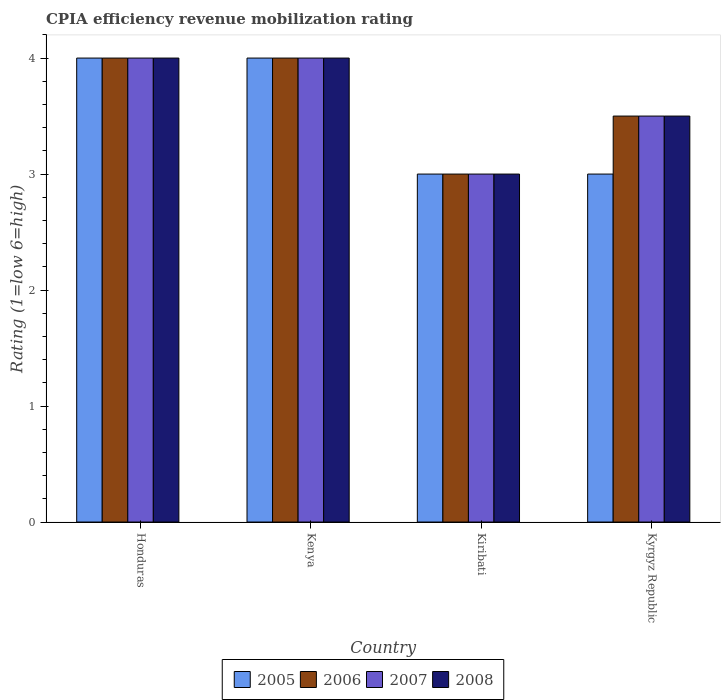How many different coloured bars are there?
Offer a terse response. 4. Are the number of bars per tick equal to the number of legend labels?
Make the answer very short. Yes. Are the number of bars on each tick of the X-axis equal?
Give a very brief answer. Yes. How many bars are there on the 2nd tick from the left?
Give a very brief answer. 4. What is the label of the 4th group of bars from the left?
Offer a very short reply. Kyrgyz Republic. In how many cases, is the number of bars for a given country not equal to the number of legend labels?
Your response must be concise. 0. What is the CPIA rating in 2005 in Honduras?
Your answer should be compact. 4. In which country was the CPIA rating in 2005 maximum?
Provide a succinct answer. Honduras. In which country was the CPIA rating in 2006 minimum?
Ensure brevity in your answer.  Kiribati. What is the difference between the CPIA rating in 2007 in Kenya and that in Kiribati?
Ensure brevity in your answer.  1. What is the difference between the CPIA rating in 2008 in Kyrgyz Republic and the CPIA rating in 2005 in Honduras?
Make the answer very short. -0.5. What is the average CPIA rating in 2007 per country?
Give a very brief answer. 3.62. What is the difference between the CPIA rating of/in 2007 and CPIA rating of/in 2008 in Honduras?
Ensure brevity in your answer.  0. In how many countries, is the CPIA rating in 2008 greater than 2.8?
Your answer should be very brief. 4. What is the ratio of the CPIA rating in 2007 in Honduras to that in Kyrgyz Republic?
Your answer should be very brief. 1.14. Is the CPIA rating in 2006 in Honduras less than that in Kenya?
Your response must be concise. No. Is the difference between the CPIA rating in 2007 in Honduras and Kenya greater than the difference between the CPIA rating in 2008 in Honduras and Kenya?
Offer a terse response. No. What is the difference between the highest and the lowest CPIA rating in 2006?
Keep it short and to the point. 1. In how many countries, is the CPIA rating in 2005 greater than the average CPIA rating in 2005 taken over all countries?
Keep it short and to the point. 2. Is the sum of the CPIA rating in 2007 in Kenya and Kiribati greater than the maximum CPIA rating in 2008 across all countries?
Provide a succinct answer. Yes. What does the 4th bar from the left in Kenya represents?
Provide a short and direct response. 2008. What does the 1st bar from the right in Kyrgyz Republic represents?
Provide a succinct answer. 2008. Are all the bars in the graph horizontal?
Provide a short and direct response. No. What is the difference between two consecutive major ticks on the Y-axis?
Your answer should be very brief. 1. Are the values on the major ticks of Y-axis written in scientific E-notation?
Your answer should be very brief. No. Does the graph contain grids?
Provide a succinct answer. No. Where does the legend appear in the graph?
Your response must be concise. Bottom center. How many legend labels are there?
Offer a very short reply. 4. How are the legend labels stacked?
Offer a very short reply. Horizontal. What is the title of the graph?
Make the answer very short. CPIA efficiency revenue mobilization rating. Does "1960" appear as one of the legend labels in the graph?
Your response must be concise. No. What is the Rating (1=low 6=high) in 2006 in Honduras?
Your answer should be compact. 4. What is the Rating (1=low 6=high) of 2008 in Honduras?
Offer a very short reply. 4. What is the Rating (1=low 6=high) of 2005 in Kenya?
Make the answer very short. 4. What is the Rating (1=low 6=high) in 2008 in Kenya?
Ensure brevity in your answer.  4. What is the Rating (1=low 6=high) in 2006 in Kiribati?
Offer a very short reply. 3. What is the Rating (1=low 6=high) in 2005 in Kyrgyz Republic?
Offer a very short reply. 3. What is the Rating (1=low 6=high) in 2006 in Kyrgyz Republic?
Your answer should be very brief. 3.5. Across all countries, what is the maximum Rating (1=low 6=high) in 2005?
Give a very brief answer. 4. Across all countries, what is the maximum Rating (1=low 6=high) of 2006?
Keep it short and to the point. 4. What is the total Rating (1=low 6=high) in 2006 in the graph?
Offer a very short reply. 14.5. What is the difference between the Rating (1=low 6=high) in 2005 in Honduras and that in Kenya?
Provide a succinct answer. 0. What is the difference between the Rating (1=low 6=high) in 2007 in Honduras and that in Kenya?
Ensure brevity in your answer.  0. What is the difference between the Rating (1=low 6=high) of 2005 in Honduras and that in Kiribati?
Your response must be concise. 1. What is the difference between the Rating (1=low 6=high) of 2007 in Honduras and that in Kiribati?
Offer a terse response. 1. What is the difference between the Rating (1=low 6=high) of 2008 in Honduras and that in Kiribati?
Make the answer very short. 1. What is the difference between the Rating (1=low 6=high) in 2006 in Kenya and that in Kiribati?
Make the answer very short. 1. What is the difference between the Rating (1=low 6=high) of 2008 in Kenya and that in Kiribati?
Provide a succinct answer. 1. What is the difference between the Rating (1=low 6=high) of 2005 in Kenya and that in Kyrgyz Republic?
Your answer should be compact. 1. What is the difference between the Rating (1=low 6=high) of 2005 in Kiribati and that in Kyrgyz Republic?
Make the answer very short. 0. What is the difference between the Rating (1=low 6=high) in 2007 in Kiribati and that in Kyrgyz Republic?
Ensure brevity in your answer.  -0.5. What is the difference between the Rating (1=low 6=high) in 2005 in Honduras and the Rating (1=low 6=high) in 2006 in Kenya?
Provide a succinct answer. 0. What is the difference between the Rating (1=low 6=high) of 2005 in Honduras and the Rating (1=low 6=high) of 2008 in Kenya?
Your answer should be very brief. 0. What is the difference between the Rating (1=low 6=high) in 2006 in Honduras and the Rating (1=low 6=high) in 2008 in Kenya?
Your response must be concise. 0. What is the difference between the Rating (1=low 6=high) in 2007 in Honduras and the Rating (1=low 6=high) in 2008 in Kenya?
Offer a very short reply. 0. What is the difference between the Rating (1=low 6=high) in 2005 in Honduras and the Rating (1=low 6=high) in 2006 in Kiribati?
Your answer should be compact. 1. What is the difference between the Rating (1=low 6=high) in 2005 in Honduras and the Rating (1=low 6=high) in 2007 in Kiribati?
Give a very brief answer. 1. What is the difference between the Rating (1=low 6=high) in 2005 in Honduras and the Rating (1=low 6=high) in 2008 in Kiribati?
Ensure brevity in your answer.  1. What is the difference between the Rating (1=low 6=high) of 2006 in Honduras and the Rating (1=low 6=high) of 2008 in Kiribati?
Your answer should be compact. 1. What is the difference between the Rating (1=low 6=high) of 2005 in Honduras and the Rating (1=low 6=high) of 2006 in Kyrgyz Republic?
Offer a terse response. 0.5. What is the difference between the Rating (1=low 6=high) in 2005 in Honduras and the Rating (1=low 6=high) in 2007 in Kyrgyz Republic?
Make the answer very short. 0.5. What is the difference between the Rating (1=low 6=high) in 2005 in Honduras and the Rating (1=low 6=high) in 2008 in Kyrgyz Republic?
Your answer should be compact. 0.5. What is the difference between the Rating (1=low 6=high) in 2006 in Honduras and the Rating (1=low 6=high) in 2008 in Kyrgyz Republic?
Ensure brevity in your answer.  0.5. What is the difference between the Rating (1=low 6=high) of 2005 in Kenya and the Rating (1=low 6=high) of 2006 in Kiribati?
Keep it short and to the point. 1. What is the difference between the Rating (1=low 6=high) of 2005 in Kenya and the Rating (1=low 6=high) of 2007 in Kiribati?
Make the answer very short. 1. What is the difference between the Rating (1=low 6=high) of 2006 in Kenya and the Rating (1=low 6=high) of 2007 in Kiribati?
Give a very brief answer. 1. What is the difference between the Rating (1=low 6=high) in 2005 in Kenya and the Rating (1=low 6=high) in 2007 in Kyrgyz Republic?
Offer a terse response. 0.5. What is the difference between the Rating (1=low 6=high) of 2005 in Kenya and the Rating (1=low 6=high) of 2008 in Kyrgyz Republic?
Your answer should be compact. 0.5. What is the difference between the Rating (1=low 6=high) of 2006 in Kenya and the Rating (1=low 6=high) of 2008 in Kyrgyz Republic?
Make the answer very short. 0.5. What is the difference between the Rating (1=low 6=high) of 2005 in Kiribati and the Rating (1=low 6=high) of 2006 in Kyrgyz Republic?
Keep it short and to the point. -0.5. What is the difference between the Rating (1=low 6=high) in 2005 in Kiribati and the Rating (1=low 6=high) in 2007 in Kyrgyz Republic?
Offer a terse response. -0.5. What is the difference between the Rating (1=low 6=high) of 2005 in Kiribati and the Rating (1=low 6=high) of 2008 in Kyrgyz Republic?
Provide a short and direct response. -0.5. What is the average Rating (1=low 6=high) in 2006 per country?
Keep it short and to the point. 3.62. What is the average Rating (1=low 6=high) of 2007 per country?
Ensure brevity in your answer.  3.62. What is the average Rating (1=low 6=high) of 2008 per country?
Your answer should be compact. 3.62. What is the difference between the Rating (1=low 6=high) of 2005 and Rating (1=low 6=high) of 2006 in Honduras?
Offer a terse response. 0. What is the difference between the Rating (1=low 6=high) in 2006 and Rating (1=low 6=high) in 2007 in Honduras?
Your answer should be compact. 0. What is the difference between the Rating (1=low 6=high) of 2005 and Rating (1=low 6=high) of 2006 in Kenya?
Make the answer very short. 0. What is the difference between the Rating (1=low 6=high) in 2005 and Rating (1=low 6=high) in 2007 in Kenya?
Make the answer very short. 0. What is the difference between the Rating (1=low 6=high) in 2006 and Rating (1=low 6=high) in 2007 in Kenya?
Ensure brevity in your answer.  0. What is the difference between the Rating (1=low 6=high) of 2006 and Rating (1=low 6=high) of 2008 in Kenya?
Your answer should be compact. 0. What is the difference between the Rating (1=low 6=high) of 2007 and Rating (1=low 6=high) of 2008 in Kenya?
Ensure brevity in your answer.  0. What is the difference between the Rating (1=low 6=high) of 2005 and Rating (1=low 6=high) of 2007 in Kiribati?
Make the answer very short. 0. What is the difference between the Rating (1=low 6=high) in 2005 and Rating (1=low 6=high) in 2008 in Kiribati?
Keep it short and to the point. 0. What is the difference between the Rating (1=low 6=high) in 2006 and Rating (1=low 6=high) in 2007 in Kiribati?
Your answer should be very brief. 0. What is the difference between the Rating (1=low 6=high) in 2005 and Rating (1=low 6=high) in 2006 in Kyrgyz Republic?
Ensure brevity in your answer.  -0.5. What is the difference between the Rating (1=low 6=high) of 2005 and Rating (1=low 6=high) of 2007 in Kyrgyz Republic?
Make the answer very short. -0.5. What is the difference between the Rating (1=low 6=high) of 2006 and Rating (1=low 6=high) of 2007 in Kyrgyz Republic?
Ensure brevity in your answer.  0. What is the difference between the Rating (1=low 6=high) of 2006 and Rating (1=low 6=high) of 2008 in Kyrgyz Republic?
Provide a succinct answer. 0. What is the difference between the Rating (1=low 6=high) of 2007 and Rating (1=low 6=high) of 2008 in Kyrgyz Republic?
Your answer should be very brief. 0. What is the ratio of the Rating (1=low 6=high) of 2007 in Honduras to that in Kenya?
Provide a short and direct response. 1. What is the ratio of the Rating (1=low 6=high) of 2008 in Honduras to that in Kenya?
Your response must be concise. 1. What is the ratio of the Rating (1=low 6=high) of 2006 in Honduras to that in Kiribati?
Offer a very short reply. 1.33. What is the ratio of the Rating (1=low 6=high) of 2008 in Honduras to that in Kiribati?
Make the answer very short. 1.33. What is the ratio of the Rating (1=low 6=high) in 2005 in Honduras to that in Kyrgyz Republic?
Your answer should be compact. 1.33. What is the ratio of the Rating (1=low 6=high) of 2006 in Honduras to that in Kyrgyz Republic?
Give a very brief answer. 1.14. What is the ratio of the Rating (1=low 6=high) in 2008 in Honduras to that in Kyrgyz Republic?
Ensure brevity in your answer.  1.14. What is the ratio of the Rating (1=low 6=high) in 2006 in Kenya to that in Kiribati?
Keep it short and to the point. 1.33. What is the ratio of the Rating (1=low 6=high) of 2007 in Kenya to that in Kiribati?
Provide a short and direct response. 1.33. What is the ratio of the Rating (1=low 6=high) in 2008 in Kenya to that in Kiribati?
Your response must be concise. 1.33. What is the ratio of the Rating (1=low 6=high) in 2007 in Kenya to that in Kyrgyz Republic?
Give a very brief answer. 1.14. What is the ratio of the Rating (1=low 6=high) of 2007 in Kiribati to that in Kyrgyz Republic?
Your response must be concise. 0.86. What is the ratio of the Rating (1=low 6=high) of 2008 in Kiribati to that in Kyrgyz Republic?
Your answer should be compact. 0.86. What is the difference between the highest and the second highest Rating (1=low 6=high) in 2005?
Provide a succinct answer. 0. What is the difference between the highest and the second highest Rating (1=low 6=high) of 2008?
Make the answer very short. 0. 